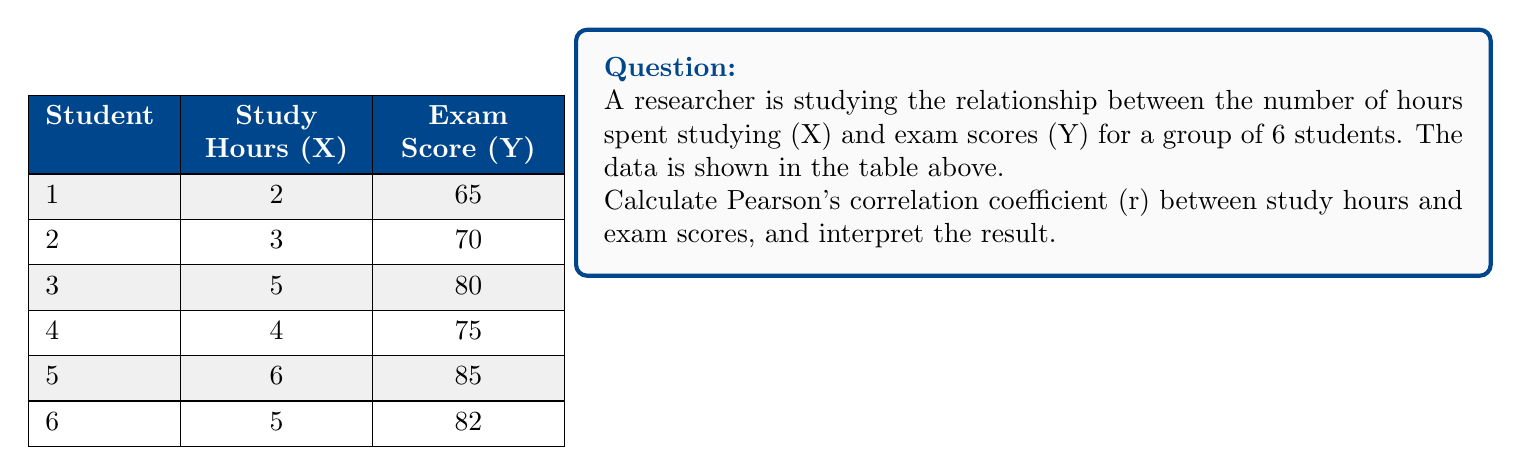Solve this math problem. To calculate Pearson's correlation coefficient (r), we'll follow these steps:

1. Calculate the means of X and Y:
   $\bar{X} = \frac{2+3+5+4+6+5}{6} = 4.17$
   $\bar{Y} = \frac{65+70+80+75+85+82}{6} = 76.17$

2. Calculate the deviations from the mean for X and Y:
   X - $\bar{X}$: -2.17, -1.17, 0.83, -0.17, 1.83, 0.83
   Y - $\bar{Y}$: -11.17, -6.17, 3.83, -1.17, 8.83, 5.83

3. Calculate the products of the deviations:
   (X - $\bar{X}$)(Y - $\bar{Y}$): 24.24, 7.22, 3.18, 0.20, 16.16, 4.84

4. Calculate the sums needed for the correlation formula:
   $\sum(X - \bar{X})(Y - \bar{Y}) = 55.84$
   $\sum(X - \bar{X})^2 = 11.83$
   $\sum(Y - \bar{Y})^2 = 283.83$

5. Apply the Pearson's correlation coefficient formula:

   $$r = \frac{\sum(X - \bar{X})(Y - \bar{Y})}{\sqrt{\sum(X - \bar{X})^2 \sum(Y - \bar{Y})^2}}$$

   $$r = \frac{55.84}{\sqrt{11.83 \times 283.83}} = \frac{55.84}{57.89} = 0.964$$

6. Interpret the result:
   The correlation coefficient r = 0.964 indicates a very strong positive linear relationship between study hours and exam scores. As the number of study hours increases, exam scores tend to increase as well. The closer r is to 1, the stronger the positive correlation, and 0.964 is very close to 1.
Answer: r = 0.964, indicating a very strong positive linear relationship between study hours and exam scores. 